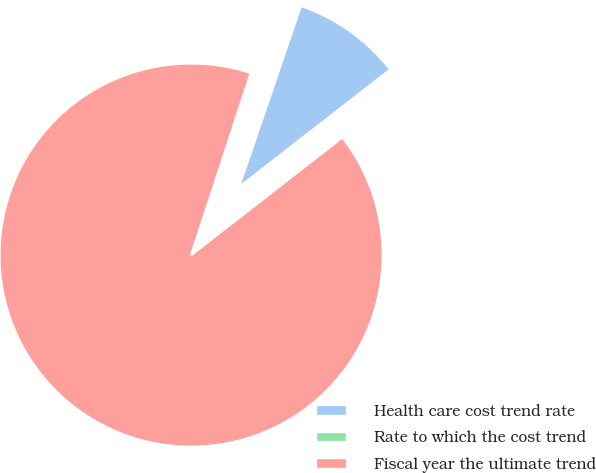<chart> <loc_0><loc_0><loc_500><loc_500><pie_chart><fcel>Health care cost trend rate<fcel>Rate to which the cost trend<fcel>Fiscal year the ultimate trend<nl><fcel>9.24%<fcel>0.2%<fcel>90.56%<nl></chart> 